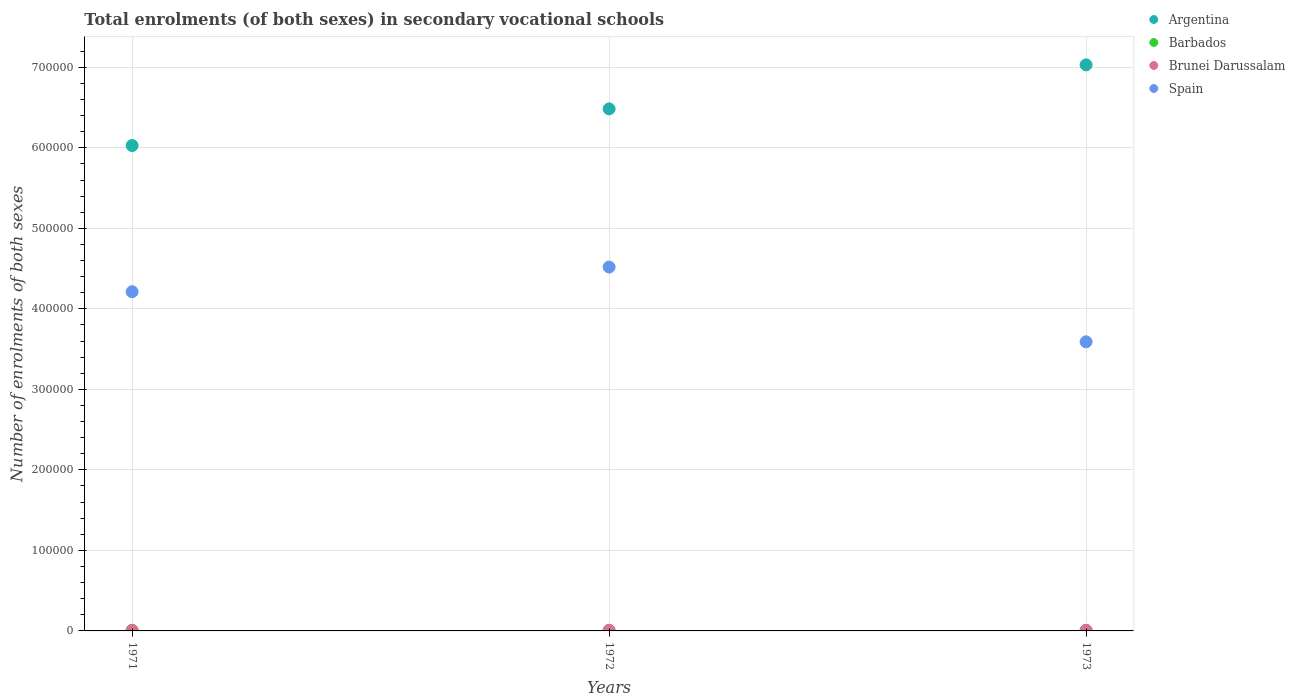How many different coloured dotlines are there?
Provide a short and direct response. 4. What is the number of enrolments in secondary schools in Brunei Darussalam in 1971?
Make the answer very short. 439. Across all years, what is the maximum number of enrolments in secondary schools in Spain?
Offer a terse response. 4.52e+05. Across all years, what is the minimum number of enrolments in secondary schools in Spain?
Your answer should be compact. 3.59e+05. In which year was the number of enrolments in secondary schools in Argentina maximum?
Give a very brief answer. 1973. In which year was the number of enrolments in secondary schools in Brunei Darussalam minimum?
Your response must be concise. 1971. What is the total number of enrolments in secondary schools in Spain in the graph?
Offer a very short reply. 1.23e+06. What is the difference between the number of enrolments in secondary schools in Spain in 1973 and the number of enrolments in secondary schools in Argentina in 1972?
Your answer should be very brief. -2.89e+05. What is the average number of enrolments in secondary schools in Spain per year?
Offer a terse response. 4.11e+05. In the year 1971, what is the difference between the number of enrolments in secondary schools in Spain and number of enrolments in secondary schools in Brunei Darussalam?
Your response must be concise. 4.21e+05. What is the ratio of the number of enrolments in secondary schools in Barbados in 1972 to that in 1973?
Offer a very short reply. 1.08. What is the difference between the highest and the second highest number of enrolments in secondary schools in Argentina?
Provide a succinct answer. 5.46e+04. What is the difference between the highest and the lowest number of enrolments in secondary schools in Spain?
Offer a very short reply. 9.28e+04. In how many years, is the number of enrolments in secondary schools in Brunei Darussalam greater than the average number of enrolments in secondary schools in Brunei Darussalam taken over all years?
Provide a succinct answer. 2. Is the sum of the number of enrolments in secondary schools in Spain in 1971 and 1973 greater than the maximum number of enrolments in secondary schools in Brunei Darussalam across all years?
Offer a very short reply. Yes. Is it the case that in every year, the sum of the number of enrolments in secondary schools in Barbados and number of enrolments in secondary schools in Brunei Darussalam  is greater than the number of enrolments in secondary schools in Argentina?
Offer a very short reply. No. Is the number of enrolments in secondary schools in Brunei Darussalam strictly greater than the number of enrolments in secondary schools in Spain over the years?
Keep it short and to the point. No. How many dotlines are there?
Keep it short and to the point. 4. What is the difference between two consecutive major ticks on the Y-axis?
Your answer should be very brief. 1.00e+05. Are the values on the major ticks of Y-axis written in scientific E-notation?
Offer a very short reply. No. Does the graph contain any zero values?
Offer a terse response. No. What is the title of the graph?
Provide a succinct answer. Total enrolments (of both sexes) in secondary vocational schools. Does "High income: OECD" appear as one of the legend labels in the graph?
Provide a short and direct response. No. What is the label or title of the Y-axis?
Ensure brevity in your answer.  Number of enrolments of both sexes. What is the Number of enrolments of both sexes in Argentina in 1971?
Provide a short and direct response. 6.03e+05. What is the Number of enrolments of both sexes of Barbados in 1971?
Provide a short and direct response. 806. What is the Number of enrolments of both sexes in Brunei Darussalam in 1971?
Your answer should be compact. 439. What is the Number of enrolments of both sexes of Spain in 1971?
Keep it short and to the point. 4.21e+05. What is the Number of enrolments of both sexes in Argentina in 1972?
Your answer should be compact. 6.48e+05. What is the Number of enrolments of both sexes of Barbados in 1972?
Offer a terse response. 822. What is the Number of enrolments of both sexes in Brunei Darussalam in 1972?
Your answer should be very brief. 638. What is the Number of enrolments of both sexes in Spain in 1972?
Your answer should be very brief. 4.52e+05. What is the Number of enrolments of both sexes in Argentina in 1973?
Ensure brevity in your answer.  7.03e+05. What is the Number of enrolments of both sexes of Barbados in 1973?
Your answer should be very brief. 761. What is the Number of enrolments of both sexes in Brunei Darussalam in 1973?
Provide a short and direct response. 666. What is the Number of enrolments of both sexes of Spain in 1973?
Keep it short and to the point. 3.59e+05. Across all years, what is the maximum Number of enrolments of both sexes in Argentina?
Offer a terse response. 7.03e+05. Across all years, what is the maximum Number of enrolments of both sexes in Barbados?
Provide a short and direct response. 822. Across all years, what is the maximum Number of enrolments of both sexes of Brunei Darussalam?
Keep it short and to the point. 666. Across all years, what is the maximum Number of enrolments of both sexes of Spain?
Offer a terse response. 4.52e+05. Across all years, what is the minimum Number of enrolments of both sexes of Argentina?
Offer a very short reply. 6.03e+05. Across all years, what is the minimum Number of enrolments of both sexes in Barbados?
Give a very brief answer. 761. Across all years, what is the minimum Number of enrolments of both sexes of Brunei Darussalam?
Provide a short and direct response. 439. Across all years, what is the minimum Number of enrolments of both sexes of Spain?
Give a very brief answer. 3.59e+05. What is the total Number of enrolments of both sexes in Argentina in the graph?
Offer a terse response. 1.95e+06. What is the total Number of enrolments of both sexes of Barbados in the graph?
Your answer should be compact. 2389. What is the total Number of enrolments of both sexes in Brunei Darussalam in the graph?
Provide a succinct answer. 1743. What is the total Number of enrolments of both sexes in Spain in the graph?
Provide a succinct answer. 1.23e+06. What is the difference between the Number of enrolments of both sexes of Argentina in 1971 and that in 1972?
Offer a terse response. -4.55e+04. What is the difference between the Number of enrolments of both sexes in Brunei Darussalam in 1971 and that in 1972?
Make the answer very short. -199. What is the difference between the Number of enrolments of both sexes of Spain in 1971 and that in 1972?
Your answer should be compact. -3.06e+04. What is the difference between the Number of enrolments of both sexes of Argentina in 1971 and that in 1973?
Provide a short and direct response. -1.00e+05. What is the difference between the Number of enrolments of both sexes in Brunei Darussalam in 1971 and that in 1973?
Offer a very short reply. -227. What is the difference between the Number of enrolments of both sexes of Spain in 1971 and that in 1973?
Offer a very short reply. 6.22e+04. What is the difference between the Number of enrolments of both sexes in Argentina in 1972 and that in 1973?
Your answer should be compact. -5.46e+04. What is the difference between the Number of enrolments of both sexes in Spain in 1972 and that in 1973?
Offer a terse response. 9.28e+04. What is the difference between the Number of enrolments of both sexes of Argentina in 1971 and the Number of enrolments of both sexes of Barbados in 1972?
Your answer should be very brief. 6.02e+05. What is the difference between the Number of enrolments of both sexes of Argentina in 1971 and the Number of enrolments of both sexes of Brunei Darussalam in 1972?
Provide a succinct answer. 6.02e+05. What is the difference between the Number of enrolments of both sexes of Argentina in 1971 and the Number of enrolments of both sexes of Spain in 1972?
Offer a terse response. 1.51e+05. What is the difference between the Number of enrolments of both sexes in Barbados in 1971 and the Number of enrolments of both sexes in Brunei Darussalam in 1972?
Ensure brevity in your answer.  168. What is the difference between the Number of enrolments of both sexes in Barbados in 1971 and the Number of enrolments of both sexes in Spain in 1972?
Your answer should be compact. -4.51e+05. What is the difference between the Number of enrolments of both sexes of Brunei Darussalam in 1971 and the Number of enrolments of both sexes of Spain in 1972?
Your answer should be very brief. -4.51e+05. What is the difference between the Number of enrolments of both sexes in Argentina in 1971 and the Number of enrolments of both sexes in Barbados in 1973?
Your answer should be compact. 6.02e+05. What is the difference between the Number of enrolments of both sexes in Argentina in 1971 and the Number of enrolments of both sexes in Brunei Darussalam in 1973?
Provide a short and direct response. 6.02e+05. What is the difference between the Number of enrolments of both sexes of Argentina in 1971 and the Number of enrolments of both sexes of Spain in 1973?
Provide a succinct answer. 2.44e+05. What is the difference between the Number of enrolments of both sexes in Barbados in 1971 and the Number of enrolments of both sexes in Brunei Darussalam in 1973?
Offer a terse response. 140. What is the difference between the Number of enrolments of both sexes of Barbados in 1971 and the Number of enrolments of both sexes of Spain in 1973?
Give a very brief answer. -3.58e+05. What is the difference between the Number of enrolments of both sexes of Brunei Darussalam in 1971 and the Number of enrolments of both sexes of Spain in 1973?
Your answer should be very brief. -3.59e+05. What is the difference between the Number of enrolments of both sexes in Argentina in 1972 and the Number of enrolments of both sexes in Barbados in 1973?
Keep it short and to the point. 6.48e+05. What is the difference between the Number of enrolments of both sexes in Argentina in 1972 and the Number of enrolments of both sexes in Brunei Darussalam in 1973?
Make the answer very short. 6.48e+05. What is the difference between the Number of enrolments of both sexes in Argentina in 1972 and the Number of enrolments of both sexes in Spain in 1973?
Provide a short and direct response. 2.89e+05. What is the difference between the Number of enrolments of both sexes of Barbados in 1972 and the Number of enrolments of both sexes of Brunei Darussalam in 1973?
Offer a very short reply. 156. What is the difference between the Number of enrolments of both sexes in Barbados in 1972 and the Number of enrolments of both sexes in Spain in 1973?
Your answer should be compact. -3.58e+05. What is the difference between the Number of enrolments of both sexes in Brunei Darussalam in 1972 and the Number of enrolments of both sexes in Spain in 1973?
Keep it short and to the point. -3.58e+05. What is the average Number of enrolments of both sexes in Argentina per year?
Give a very brief answer. 6.51e+05. What is the average Number of enrolments of both sexes in Barbados per year?
Your answer should be compact. 796.33. What is the average Number of enrolments of both sexes of Brunei Darussalam per year?
Provide a short and direct response. 581. What is the average Number of enrolments of both sexes in Spain per year?
Provide a succinct answer. 4.11e+05. In the year 1971, what is the difference between the Number of enrolments of both sexes of Argentina and Number of enrolments of both sexes of Barbados?
Your answer should be compact. 6.02e+05. In the year 1971, what is the difference between the Number of enrolments of both sexes in Argentina and Number of enrolments of both sexes in Brunei Darussalam?
Your response must be concise. 6.02e+05. In the year 1971, what is the difference between the Number of enrolments of both sexes of Argentina and Number of enrolments of both sexes of Spain?
Provide a short and direct response. 1.82e+05. In the year 1971, what is the difference between the Number of enrolments of both sexes in Barbados and Number of enrolments of both sexes in Brunei Darussalam?
Your answer should be very brief. 367. In the year 1971, what is the difference between the Number of enrolments of both sexes of Barbados and Number of enrolments of both sexes of Spain?
Ensure brevity in your answer.  -4.20e+05. In the year 1971, what is the difference between the Number of enrolments of both sexes in Brunei Darussalam and Number of enrolments of both sexes in Spain?
Provide a succinct answer. -4.21e+05. In the year 1972, what is the difference between the Number of enrolments of both sexes of Argentina and Number of enrolments of both sexes of Barbados?
Provide a succinct answer. 6.48e+05. In the year 1972, what is the difference between the Number of enrolments of both sexes of Argentina and Number of enrolments of both sexes of Brunei Darussalam?
Give a very brief answer. 6.48e+05. In the year 1972, what is the difference between the Number of enrolments of both sexes of Argentina and Number of enrolments of both sexes of Spain?
Keep it short and to the point. 1.96e+05. In the year 1972, what is the difference between the Number of enrolments of both sexes in Barbados and Number of enrolments of both sexes in Brunei Darussalam?
Provide a short and direct response. 184. In the year 1972, what is the difference between the Number of enrolments of both sexes of Barbados and Number of enrolments of both sexes of Spain?
Ensure brevity in your answer.  -4.51e+05. In the year 1972, what is the difference between the Number of enrolments of both sexes in Brunei Darussalam and Number of enrolments of both sexes in Spain?
Your answer should be very brief. -4.51e+05. In the year 1973, what is the difference between the Number of enrolments of both sexes in Argentina and Number of enrolments of both sexes in Barbados?
Offer a very short reply. 7.02e+05. In the year 1973, what is the difference between the Number of enrolments of both sexes of Argentina and Number of enrolments of both sexes of Brunei Darussalam?
Your response must be concise. 7.02e+05. In the year 1973, what is the difference between the Number of enrolments of both sexes of Argentina and Number of enrolments of both sexes of Spain?
Your answer should be compact. 3.44e+05. In the year 1973, what is the difference between the Number of enrolments of both sexes of Barbados and Number of enrolments of both sexes of Brunei Darussalam?
Make the answer very short. 95. In the year 1973, what is the difference between the Number of enrolments of both sexes in Barbados and Number of enrolments of both sexes in Spain?
Keep it short and to the point. -3.58e+05. In the year 1973, what is the difference between the Number of enrolments of both sexes in Brunei Darussalam and Number of enrolments of both sexes in Spain?
Provide a short and direct response. -3.58e+05. What is the ratio of the Number of enrolments of both sexes in Argentina in 1971 to that in 1972?
Your answer should be compact. 0.93. What is the ratio of the Number of enrolments of both sexes in Barbados in 1971 to that in 1972?
Your answer should be very brief. 0.98. What is the ratio of the Number of enrolments of both sexes in Brunei Darussalam in 1971 to that in 1972?
Your answer should be very brief. 0.69. What is the ratio of the Number of enrolments of both sexes in Spain in 1971 to that in 1972?
Keep it short and to the point. 0.93. What is the ratio of the Number of enrolments of both sexes in Argentina in 1971 to that in 1973?
Your answer should be compact. 0.86. What is the ratio of the Number of enrolments of both sexes in Barbados in 1971 to that in 1973?
Provide a succinct answer. 1.06. What is the ratio of the Number of enrolments of both sexes of Brunei Darussalam in 1971 to that in 1973?
Provide a short and direct response. 0.66. What is the ratio of the Number of enrolments of both sexes in Spain in 1971 to that in 1973?
Offer a very short reply. 1.17. What is the ratio of the Number of enrolments of both sexes in Argentina in 1972 to that in 1973?
Ensure brevity in your answer.  0.92. What is the ratio of the Number of enrolments of both sexes of Barbados in 1972 to that in 1973?
Offer a very short reply. 1.08. What is the ratio of the Number of enrolments of both sexes of Brunei Darussalam in 1972 to that in 1973?
Provide a succinct answer. 0.96. What is the ratio of the Number of enrolments of both sexes in Spain in 1972 to that in 1973?
Your answer should be compact. 1.26. What is the difference between the highest and the second highest Number of enrolments of both sexes of Argentina?
Provide a succinct answer. 5.46e+04. What is the difference between the highest and the second highest Number of enrolments of both sexes in Barbados?
Give a very brief answer. 16. What is the difference between the highest and the second highest Number of enrolments of both sexes of Brunei Darussalam?
Your response must be concise. 28. What is the difference between the highest and the second highest Number of enrolments of both sexes of Spain?
Make the answer very short. 3.06e+04. What is the difference between the highest and the lowest Number of enrolments of both sexes in Argentina?
Make the answer very short. 1.00e+05. What is the difference between the highest and the lowest Number of enrolments of both sexes of Brunei Darussalam?
Provide a short and direct response. 227. What is the difference between the highest and the lowest Number of enrolments of both sexes in Spain?
Your answer should be very brief. 9.28e+04. 